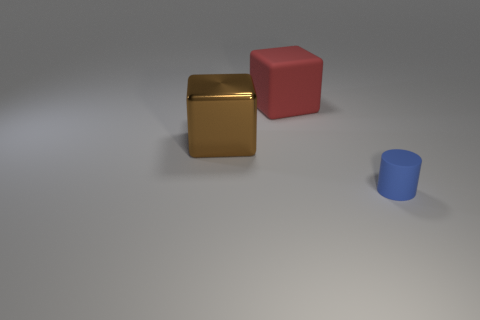Are there any cylinders that are behind the thing that is right of the matte object behind the tiny blue rubber object? Yes, there are no cylinders positioned behind the cube which is to the right of the matte object, which in this case is the golden cube located behind the small blue cylinder. 